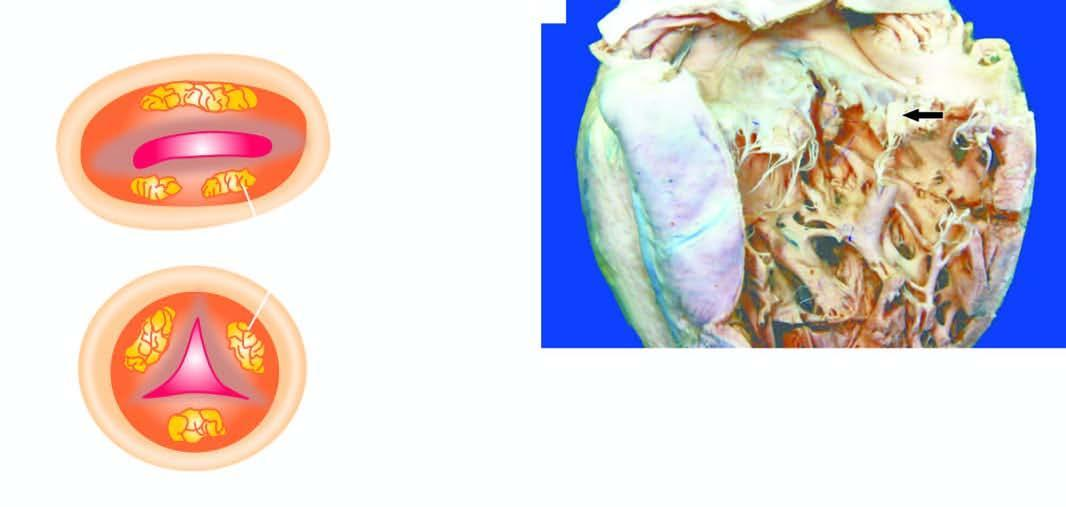re cells shown on the mitral valve are shown as seen from the left ventricle?
Answer the question using a single word or phrase. No 